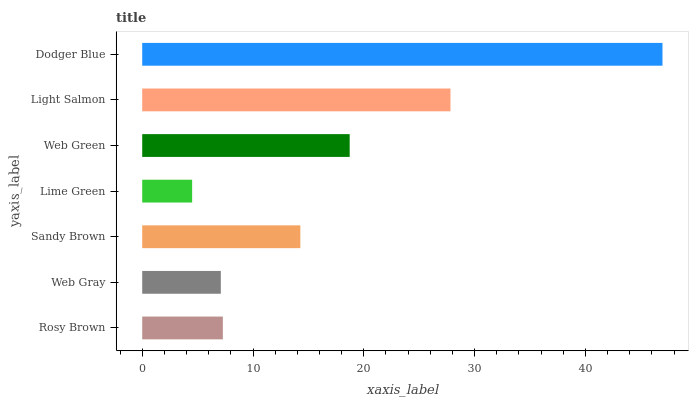Is Lime Green the minimum?
Answer yes or no. Yes. Is Dodger Blue the maximum?
Answer yes or no. Yes. Is Web Gray the minimum?
Answer yes or no. No. Is Web Gray the maximum?
Answer yes or no. No. Is Rosy Brown greater than Web Gray?
Answer yes or no. Yes. Is Web Gray less than Rosy Brown?
Answer yes or no. Yes. Is Web Gray greater than Rosy Brown?
Answer yes or no. No. Is Rosy Brown less than Web Gray?
Answer yes or no. No. Is Sandy Brown the high median?
Answer yes or no. Yes. Is Sandy Brown the low median?
Answer yes or no. Yes. Is Dodger Blue the high median?
Answer yes or no. No. Is Rosy Brown the low median?
Answer yes or no. No. 